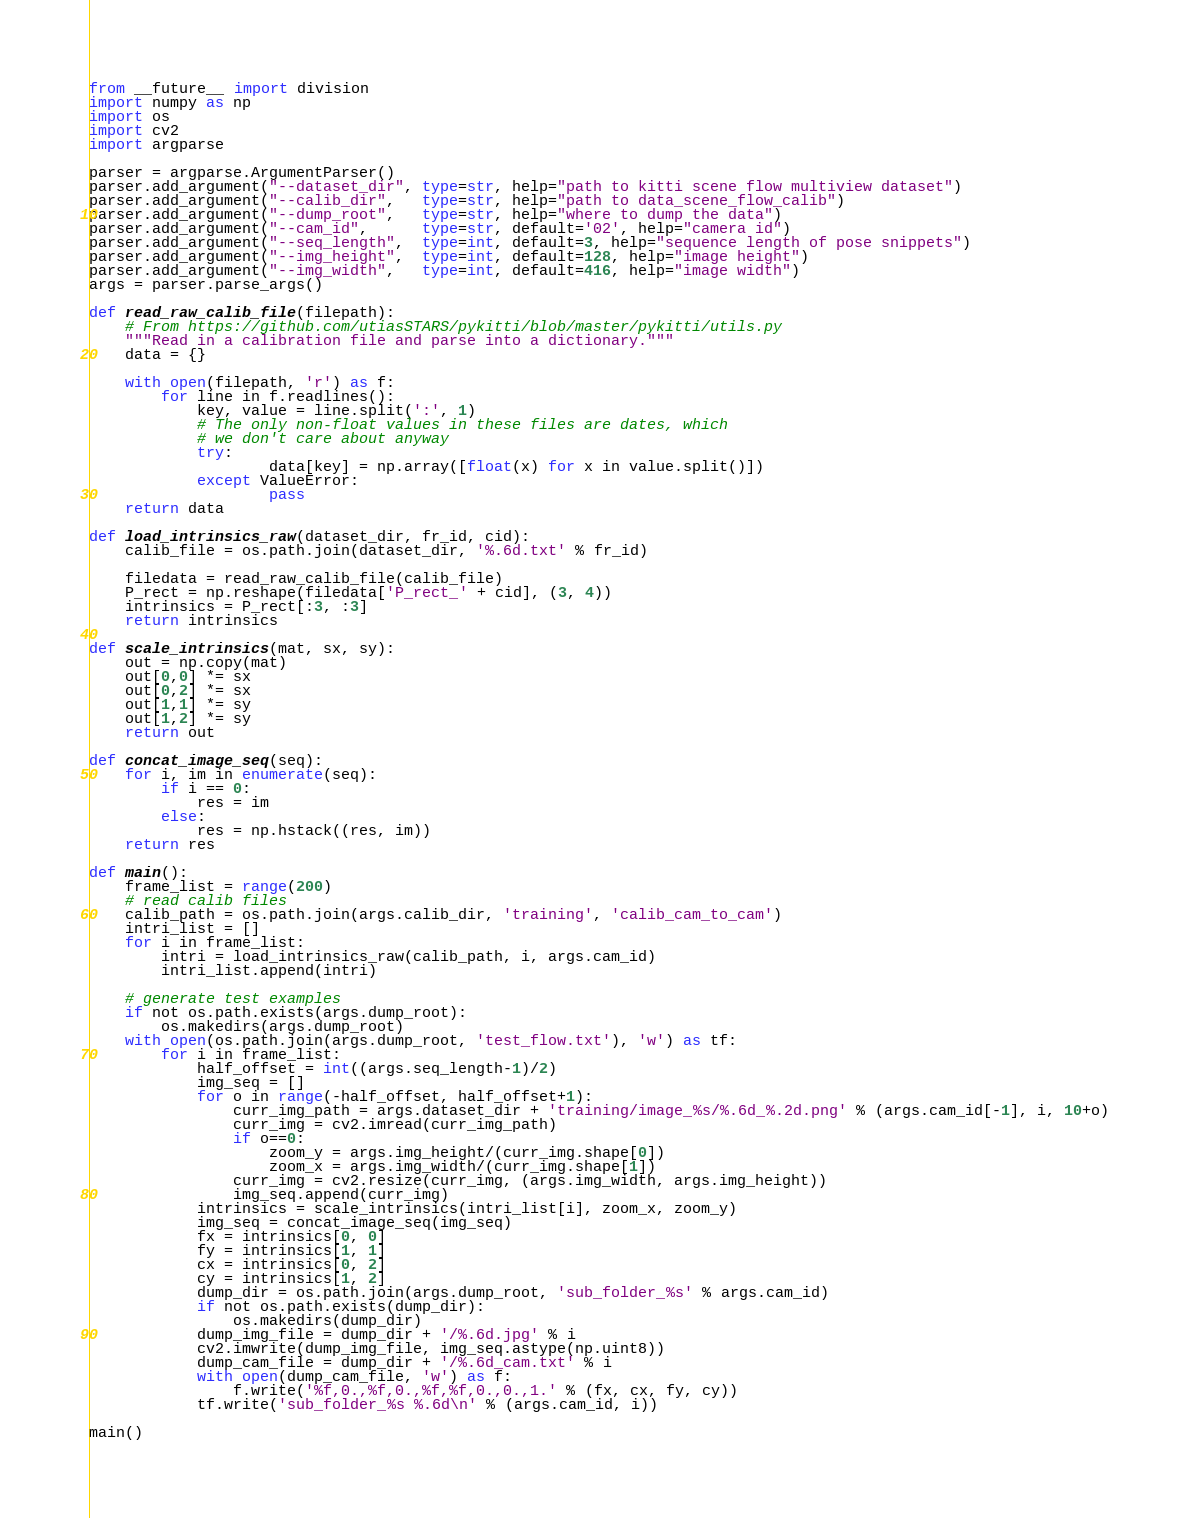Convert code to text. <code><loc_0><loc_0><loc_500><loc_500><_Python_>from __future__ import division
import numpy as np
import os
import cv2
import argparse

parser = argparse.ArgumentParser()
parser.add_argument("--dataset_dir", type=str, help="path to kitti scene flow multiview dataset")
parser.add_argument("--calib_dir",   type=str, help="path to data_scene_flow_calib")
parser.add_argument("--dump_root",   type=str, help="where to dump the data")
parser.add_argument("--cam_id",      type=str, default='02', help="camera id")
parser.add_argument("--seq_length",  type=int, default=3, help="sequence length of pose snippets")
parser.add_argument("--img_height",  type=int, default=128, help="image height")
parser.add_argument("--img_width",   type=int, default=416, help="image width")
args = parser.parse_args()

def read_raw_calib_file(filepath):
    # From https://github.com/utiasSTARS/pykitti/blob/master/pykitti/utils.py
    """Read in a calibration file and parse into a dictionary."""
    data = {}

    with open(filepath, 'r') as f:
        for line in f.readlines():
            key, value = line.split(':', 1)
            # The only non-float values in these files are dates, which
            # we don't care about anyway
            try:
                    data[key] = np.array([float(x) for x in value.split()])
            except ValueError:
                    pass
    return data

def load_intrinsics_raw(dataset_dir, fr_id, cid):
    calib_file = os.path.join(dataset_dir, '%.6d.txt' % fr_id)

    filedata = read_raw_calib_file(calib_file)
    P_rect = np.reshape(filedata['P_rect_' + cid], (3, 4))
    intrinsics = P_rect[:3, :3]
    return intrinsics

def scale_intrinsics(mat, sx, sy):
    out = np.copy(mat)
    out[0,0] *= sx
    out[0,2] *= sx
    out[1,1] *= sy
    out[1,2] *= sy
    return out

def concat_image_seq(seq):
    for i, im in enumerate(seq):
        if i == 0:
            res = im
        else:
            res = np.hstack((res, im))
    return res

def main():
    frame_list = range(200)
    # read calib files
    calib_path = os.path.join(args.calib_dir, 'training', 'calib_cam_to_cam')
    intri_list = []
    for i in frame_list:
        intri = load_intrinsics_raw(calib_path, i, args.cam_id)
        intri_list.append(intri)

    # generate test examples
    if not os.path.exists(args.dump_root):
        os.makedirs(args.dump_root)
    with open(os.path.join(args.dump_root, 'test_flow.txt'), 'w') as tf:
        for i in frame_list:
            half_offset = int((args.seq_length-1)/2)
            img_seq = []
            for o in range(-half_offset, half_offset+1):
                curr_img_path = args.dataset_dir + 'training/image_%s/%.6d_%.2d.png' % (args.cam_id[-1], i, 10+o)
                curr_img = cv2.imread(curr_img_path)
                if o==0:
                    zoom_y = args.img_height/(curr_img.shape[0])
                    zoom_x = args.img_width/(curr_img.shape[1])
                curr_img = cv2.resize(curr_img, (args.img_width, args.img_height))
                img_seq.append(curr_img)
            intrinsics = scale_intrinsics(intri_list[i], zoom_x, zoom_y)
            img_seq = concat_image_seq(img_seq)
            fx = intrinsics[0, 0]
            fy = intrinsics[1, 1]
            cx = intrinsics[0, 2]
            cy = intrinsics[1, 2]
            dump_dir = os.path.join(args.dump_root, 'sub_folder_%s' % args.cam_id)
            if not os.path.exists(dump_dir):
                os.makedirs(dump_dir)
            dump_img_file = dump_dir + '/%.6d.jpg' % i
            cv2.imwrite(dump_img_file, img_seq.astype(np.uint8))
            dump_cam_file = dump_dir + '/%.6d_cam.txt' % i
            with open(dump_cam_file, 'w') as f:
                f.write('%f,0.,%f,0.,%f,%f,0.,0.,1.' % (fx, cx, fy, cy))
            tf.write('sub_folder_%s %.6d\n' % (args.cam_id, i))

main()
</code> 